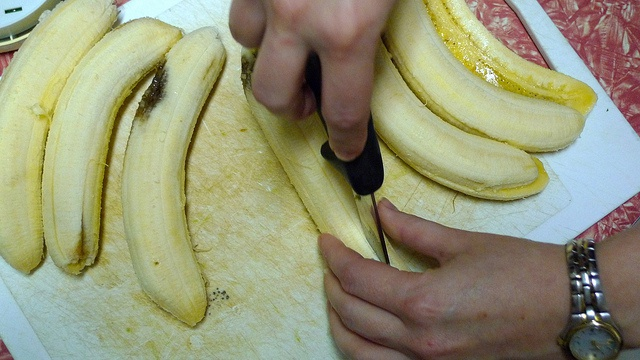Describe the objects in this image and their specific colors. I can see people in lightblue, gray, maroon, and black tones, banana in lightblue, olive, tan, and beige tones, banana in lightblue, khaki, tan, and beige tones, banana in lightblue, beige, olive, and tan tones, and banana in lightblue, khaki, and tan tones in this image. 